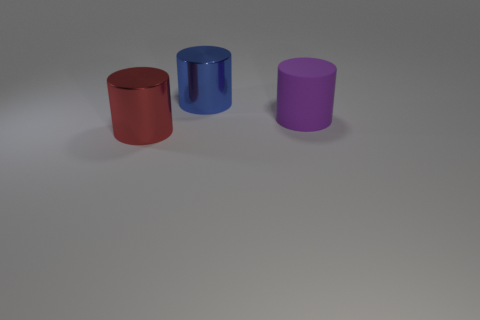Is there any other thing that has the same material as the purple object?
Provide a succinct answer. No. Is the number of red shiny things in front of the large red cylinder less than the number of big shiny cylinders to the left of the purple rubber cylinder?
Offer a very short reply. Yes. There is another rubber object that is the same shape as the large red thing; what color is it?
Offer a very short reply. Purple. What number of big things are both in front of the large blue cylinder and to the left of the purple thing?
Your answer should be very brief. 1. Is the number of large blue metallic objects in front of the big purple cylinder greater than the number of blue things on the left side of the large red cylinder?
Your answer should be very brief. No. How big is the blue thing?
Provide a short and direct response. Large. Are there any big yellow rubber things that have the same shape as the red shiny object?
Offer a terse response. No. Does the red shiny object have the same shape as the large blue thing that is on the right side of the red cylinder?
Ensure brevity in your answer.  Yes. There is a object that is in front of the blue cylinder and on the right side of the red metal thing; what is its size?
Give a very brief answer. Large. What number of purple matte cylinders are there?
Give a very brief answer. 1. 